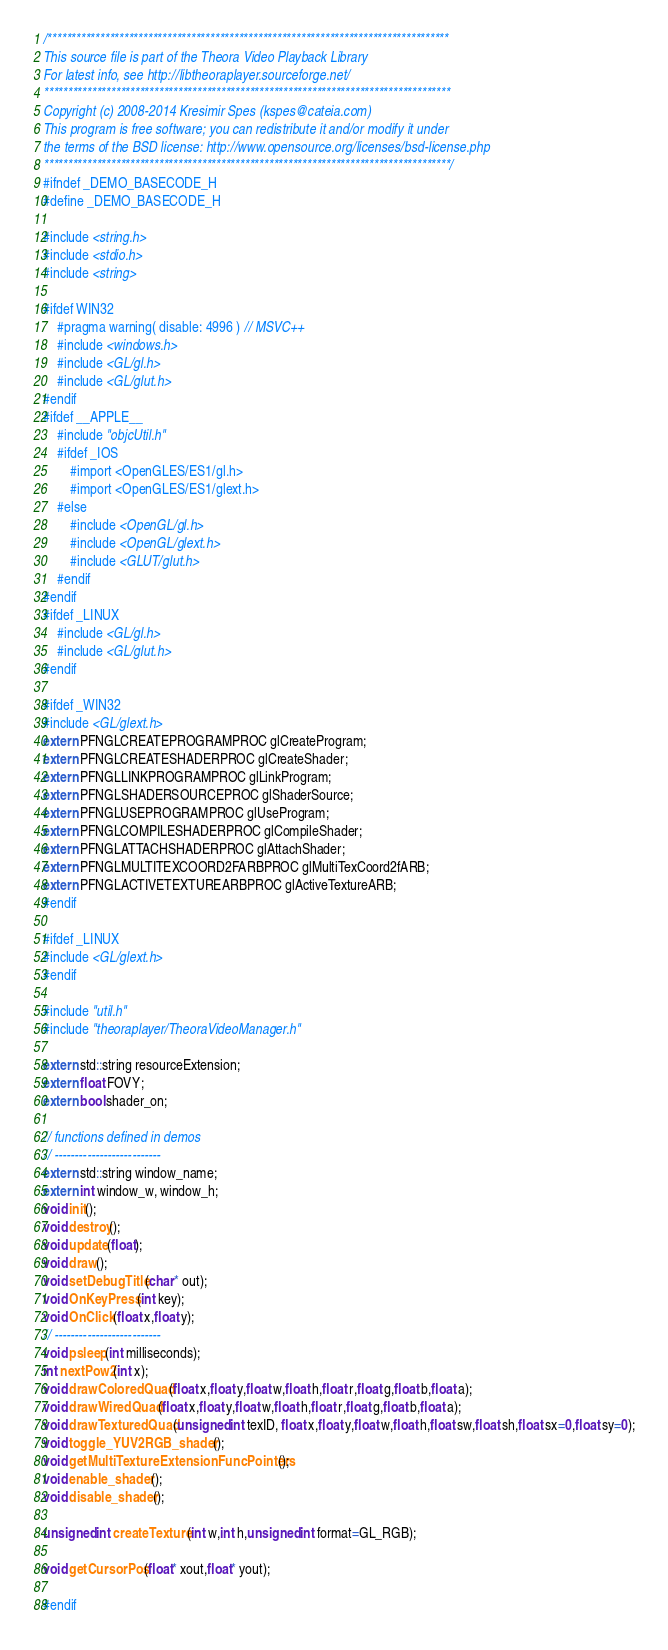Convert code to text. <code><loc_0><loc_0><loc_500><loc_500><_C_>/************************************************************************************
This source file is part of the Theora Video Playback Library
For latest info, see http://libtheoraplayer.sourceforge.net/
*************************************************************************************
Copyright (c) 2008-2014 Kresimir Spes (kspes@cateia.com)
This program is free software; you can redistribute it and/or modify it under
the terms of the BSD license: http://www.opensource.org/licenses/bsd-license.php
*************************************************************************************/
#ifndef _DEMO_BASECODE_H
#define _DEMO_BASECODE_H

#include <string.h>
#include <stdio.h>
#include <string>

#ifdef WIN32
	#pragma warning( disable: 4996 ) // MSVC++
	#include <windows.h>
	#include <GL/gl.h>
	#include <GL/glut.h>
#endif
#ifdef __APPLE__
	#include "objcUtil.h"
	#ifdef _IOS
		#import <OpenGLES/ES1/gl.h>
		#import <OpenGLES/ES1/glext.h>
	#else
		#include <OpenGL/gl.h>
		#include <OpenGL/glext.h>
		#include <GLUT/glut.h>
	#endif
#endif
#ifdef _LINUX
	#include <GL/gl.h>
	#include <GL/glut.h>
#endif

#ifdef _WIN32
#include <GL/glext.h>
extern PFNGLCREATEPROGRAMPROC glCreateProgram;
extern PFNGLCREATESHADERPROC glCreateShader;
extern PFNGLLINKPROGRAMPROC glLinkProgram;
extern PFNGLSHADERSOURCEPROC glShaderSource;
extern PFNGLUSEPROGRAMPROC glUseProgram;
extern PFNGLCOMPILESHADERPROC glCompileShader;
extern PFNGLATTACHSHADERPROC glAttachShader;
extern PFNGLMULTITEXCOORD2FARBPROC glMultiTexCoord2fARB;
extern PFNGLACTIVETEXTUREARBPROC glActiveTextureARB;
#endif

#ifdef _LINUX
#include <GL/glext.h>
#endif

#include "util.h"
#include "theoraplayer/TheoraVideoManager.h"

extern std::string resourceExtension;
extern float FOVY;
extern bool shader_on;

// functions defined in demos
// --------------------------
extern std::string window_name;
extern int window_w, window_h;
void init();
void destroy();
void update(float);
void draw();
void setDebugTitle(char* out);
void OnKeyPress(int key);
void OnClick(float x,float y);
// --------------------------
void psleep(int milliseconds);
int nextPow2(int x);
void drawColoredQuad(float x,float y,float w,float h,float r,float g,float b,float a);
void drawWiredQuad(float x,float y,float w,float h,float r,float g,float b,float a);
void drawTexturedQuad(unsigned int texID, float x,float y,float w,float h,float sw,float sh,float sx=0,float sy=0);
void toggle_YUV2RGB_shader();
void getMultiTextureExtensionFuncPointers();
void enable_shader();
void disable_shader();

unsigned int createTexture(int w,int h,unsigned int format=GL_RGB);

void getCursorPos(float* xout,float* yout);

#endif
</code> 